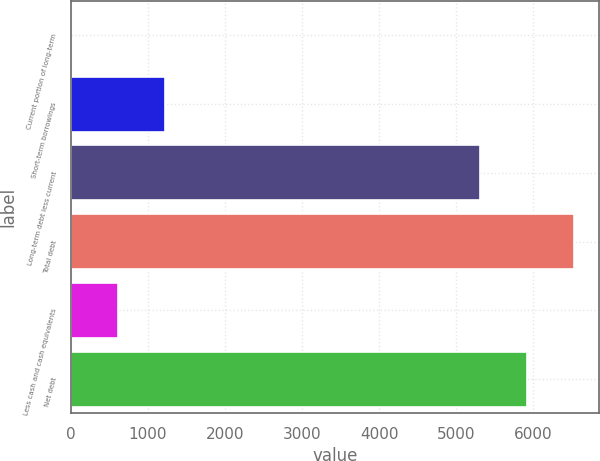<chart> <loc_0><loc_0><loc_500><loc_500><bar_chart><fcel>Current portion of long-term<fcel>Short-term borrowings<fcel>Long-term debt less current<fcel>Total debt<fcel>Less cash and cash equivalents<fcel>Net debt<nl><fcel>5.4<fcel>1224.96<fcel>5309<fcel>6528.56<fcel>615.18<fcel>5918.78<nl></chart> 